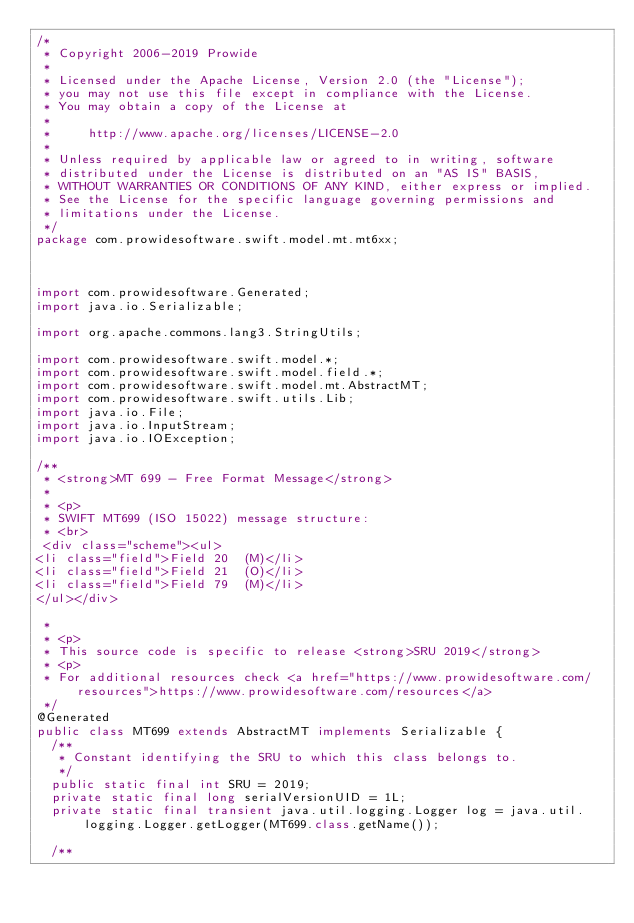Convert code to text. <code><loc_0><loc_0><loc_500><loc_500><_Java_>/*
 * Copyright 2006-2019 Prowide
 *
 * Licensed under the Apache License, Version 2.0 (the "License");
 * you may not use this file except in compliance with the License.
 * You may obtain a copy of the License at
 *
 *     http://www.apache.org/licenses/LICENSE-2.0
 *
 * Unless required by applicable law or agreed to in writing, software
 * distributed under the License is distributed on an "AS IS" BASIS,
 * WITHOUT WARRANTIES OR CONDITIONS OF ANY KIND, either express or implied.
 * See the License for the specific language governing permissions and
 * limitations under the License.
 */
package com.prowidesoftware.swift.model.mt.mt6xx;



import com.prowidesoftware.Generated;
import java.io.Serializable;

import org.apache.commons.lang3.StringUtils;

import com.prowidesoftware.swift.model.*;
import com.prowidesoftware.swift.model.field.*;
import com.prowidesoftware.swift.model.mt.AbstractMT;
import com.prowidesoftware.swift.utils.Lib;
import java.io.File;
import java.io.InputStream;
import java.io.IOException;

/**
 * <strong>MT 699 - Free Format Message</strong>
 *
 * <p>
 * SWIFT MT699 (ISO 15022) message structure:
 * <br>
 <div class="scheme"><ul>
<li class="field">Field 20  (M)</li>
<li class="field">Field 21  (O)</li>
<li class="field">Field 79  (M)</li>
</ul></div>

 *
 * <p>
 * This source code is specific to release <strong>SRU 2019</strong>
 * <p>
 * For additional resources check <a href="https://www.prowidesoftware.com/resources">https://www.prowidesoftware.com/resources</a>
 */
@Generated
public class MT699 extends AbstractMT implements Serializable {
	/**
	 * Constant identifying the SRU to which this class belongs to.
	 */
	public static final int SRU = 2019;
	private static final long serialVersionUID = 1L;
	private static final transient java.util.logging.Logger log = java.util.logging.Logger.getLogger(MT699.class.getName());
	
	/**</code> 